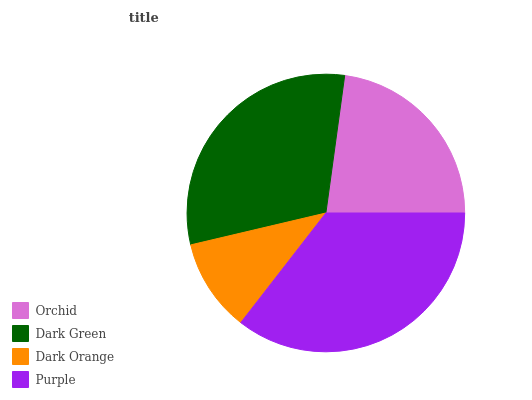Is Dark Orange the minimum?
Answer yes or no. Yes. Is Purple the maximum?
Answer yes or no. Yes. Is Dark Green the minimum?
Answer yes or no. No. Is Dark Green the maximum?
Answer yes or no. No. Is Dark Green greater than Orchid?
Answer yes or no. Yes. Is Orchid less than Dark Green?
Answer yes or no. Yes. Is Orchid greater than Dark Green?
Answer yes or no. No. Is Dark Green less than Orchid?
Answer yes or no. No. Is Dark Green the high median?
Answer yes or no. Yes. Is Orchid the low median?
Answer yes or no. Yes. Is Purple the high median?
Answer yes or no. No. Is Dark Green the low median?
Answer yes or no. No. 